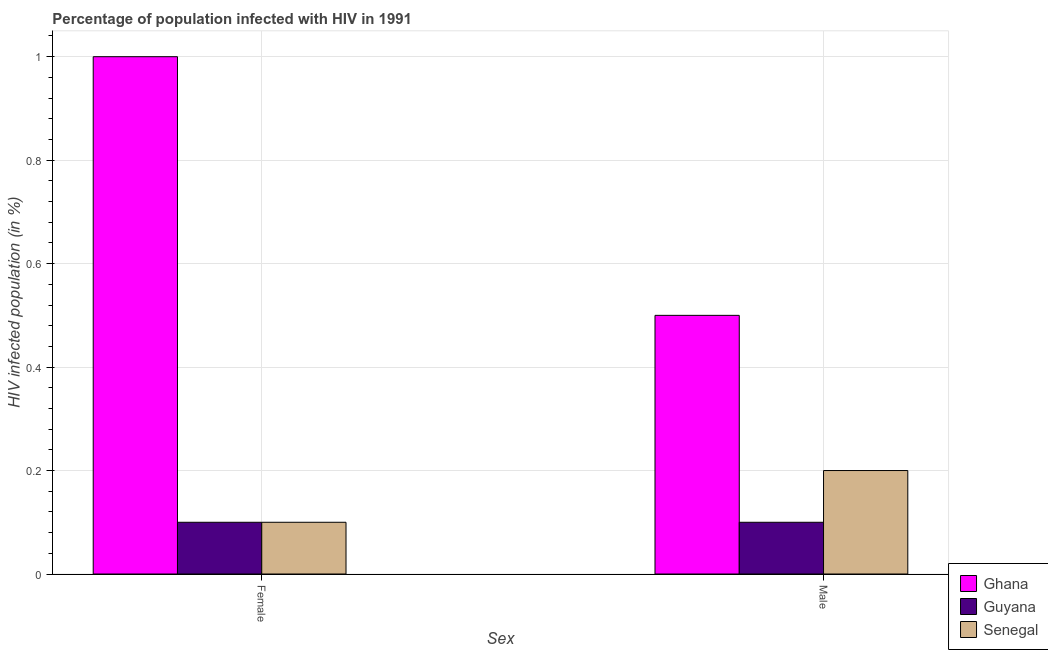How many different coloured bars are there?
Your response must be concise. 3. How many groups of bars are there?
Your answer should be very brief. 2. Are the number of bars per tick equal to the number of legend labels?
Give a very brief answer. Yes. Are the number of bars on each tick of the X-axis equal?
Provide a succinct answer. Yes. What is the percentage of males who are infected with hiv in Senegal?
Provide a short and direct response. 0.2. Across all countries, what is the maximum percentage of females who are infected with hiv?
Keep it short and to the point. 1. Across all countries, what is the minimum percentage of females who are infected with hiv?
Your response must be concise. 0.1. In which country was the percentage of males who are infected with hiv minimum?
Offer a terse response. Guyana. What is the total percentage of females who are infected with hiv in the graph?
Ensure brevity in your answer.  1.2. What is the difference between the percentage of males who are infected with hiv in Ghana and that in Senegal?
Your answer should be very brief. 0.3. What is the difference between the percentage of females who are infected with hiv in Senegal and the percentage of males who are infected with hiv in Guyana?
Your answer should be very brief. 0. What is the average percentage of males who are infected with hiv per country?
Ensure brevity in your answer.  0.27. What is the difference between the percentage of females who are infected with hiv and percentage of males who are infected with hiv in Ghana?
Offer a very short reply. 0.5. What is the ratio of the percentage of males who are infected with hiv in Guyana to that in Senegal?
Ensure brevity in your answer.  0.5. Is the percentage of males who are infected with hiv in Senegal less than that in Guyana?
Give a very brief answer. No. In how many countries, is the percentage of females who are infected with hiv greater than the average percentage of females who are infected with hiv taken over all countries?
Your response must be concise. 1. What does the 3rd bar from the left in Female represents?
Make the answer very short. Senegal. What does the 2nd bar from the right in Female represents?
Give a very brief answer. Guyana. Are the values on the major ticks of Y-axis written in scientific E-notation?
Provide a succinct answer. No. Does the graph contain any zero values?
Your response must be concise. No. How many legend labels are there?
Keep it short and to the point. 3. What is the title of the graph?
Make the answer very short. Percentage of population infected with HIV in 1991. What is the label or title of the X-axis?
Keep it short and to the point. Sex. What is the label or title of the Y-axis?
Ensure brevity in your answer.  HIV infected population (in %). What is the HIV infected population (in %) of Guyana in Female?
Keep it short and to the point. 0.1. What is the HIV infected population (in %) of Senegal in Female?
Ensure brevity in your answer.  0.1. What is the HIV infected population (in %) in Ghana in Male?
Make the answer very short. 0.5. What is the HIV infected population (in %) of Guyana in Male?
Give a very brief answer. 0.1. Across all Sex, what is the maximum HIV infected population (in %) in Senegal?
Provide a succinct answer. 0.2. Across all Sex, what is the minimum HIV infected population (in %) of Ghana?
Your answer should be compact. 0.5. Across all Sex, what is the minimum HIV infected population (in %) in Guyana?
Offer a very short reply. 0.1. What is the total HIV infected population (in %) in Ghana in the graph?
Give a very brief answer. 1.5. What is the total HIV infected population (in %) of Guyana in the graph?
Your response must be concise. 0.2. What is the difference between the HIV infected population (in %) of Ghana in Female and that in Male?
Provide a short and direct response. 0.5. What is the difference between the HIV infected population (in %) of Senegal in Female and that in Male?
Offer a very short reply. -0.1. What is the difference between the HIV infected population (in %) of Ghana in Female and the HIV infected population (in %) of Senegal in Male?
Your answer should be compact. 0.8. What is the average HIV infected population (in %) in Ghana per Sex?
Your answer should be very brief. 0.75. What is the average HIV infected population (in %) in Guyana per Sex?
Offer a terse response. 0.1. What is the average HIV infected population (in %) in Senegal per Sex?
Your answer should be very brief. 0.15. What is the difference between the HIV infected population (in %) of Ghana and HIV infected population (in %) of Senegal in Female?
Give a very brief answer. 0.9. What is the difference between the HIV infected population (in %) of Guyana and HIV infected population (in %) of Senegal in Female?
Ensure brevity in your answer.  0. What is the difference between the HIV infected population (in %) in Ghana and HIV infected population (in %) in Guyana in Male?
Ensure brevity in your answer.  0.4. What is the difference between the HIV infected population (in %) of Guyana and HIV infected population (in %) of Senegal in Male?
Your answer should be compact. -0.1. What is the ratio of the HIV infected population (in %) in Ghana in Female to that in Male?
Give a very brief answer. 2. What is the difference between the highest and the second highest HIV infected population (in %) of Guyana?
Provide a short and direct response. 0. What is the difference between the highest and the lowest HIV infected population (in %) of Ghana?
Offer a terse response. 0.5. What is the difference between the highest and the lowest HIV infected population (in %) of Guyana?
Provide a succinct answer. 0. What is the difference between the highest and the lowest HIV infected population (in %) of Senegal?
Your response must be concise. 0.1. 